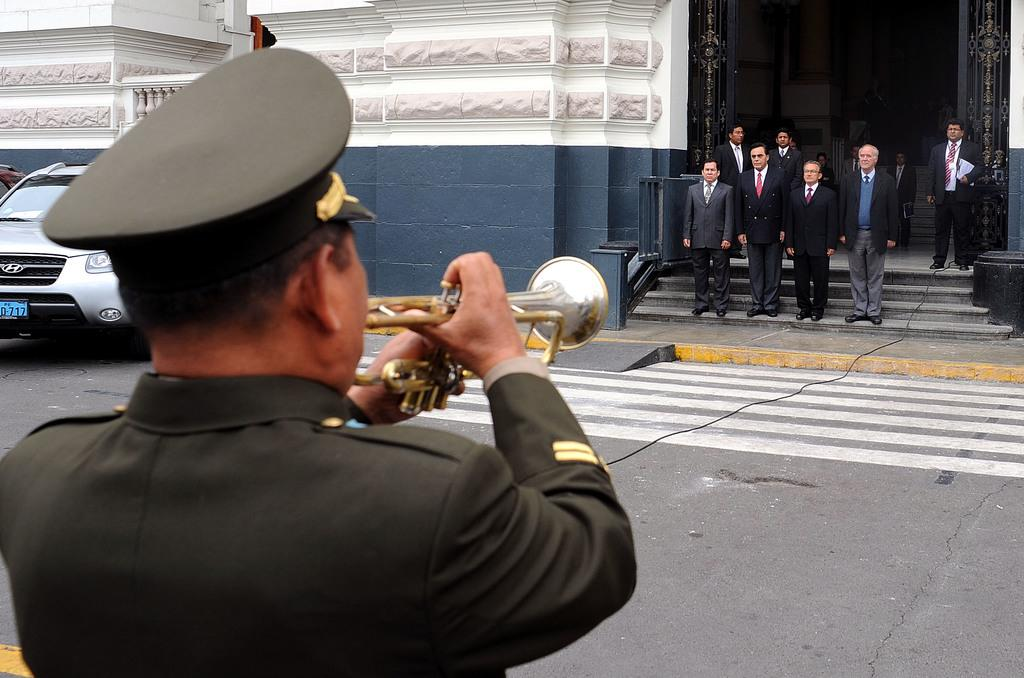What is the main subject in the foreground of the image? There is a person playing a musical instrument in the foreground of the image. What can be seen in the background of the image? There are people, a building, and a car in the background of the image. What is at the bottom of the image? There is a road at the bottom of the image. What type of soap is being used by the person playing the musical instrument in the image? There is no soap present in the image; the person is playing a musical instrument. How many eggs are visible in the image? There are no eggs present in the image. 